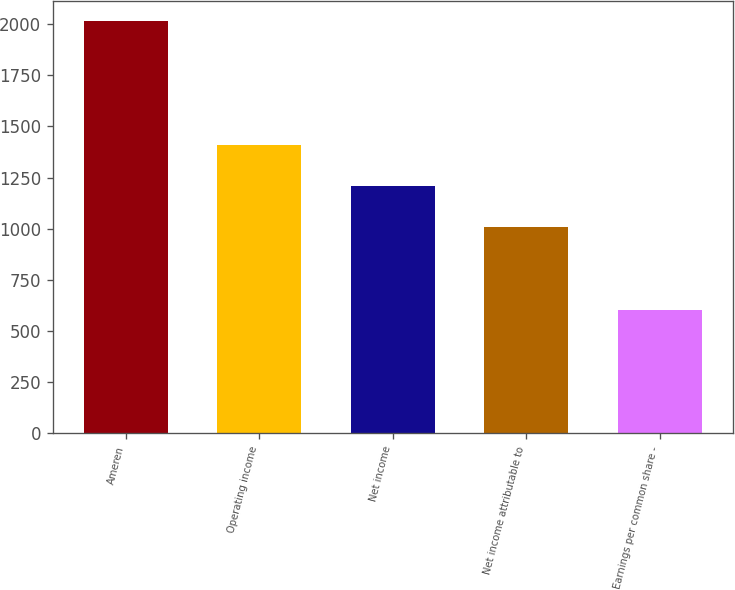<chart> <loc_0><loc_0><loc_500><loc_500><bar_chart><fcel>Ameren<fcel>Operating income<fcel>Net income<fcel>Net income attributable to<fcel>Earnings per common share -<nl><fcel>2014<fcel>1409.85<fcel>1208.47<fcel>1007.09<fcel>604.33<nl></chart> 